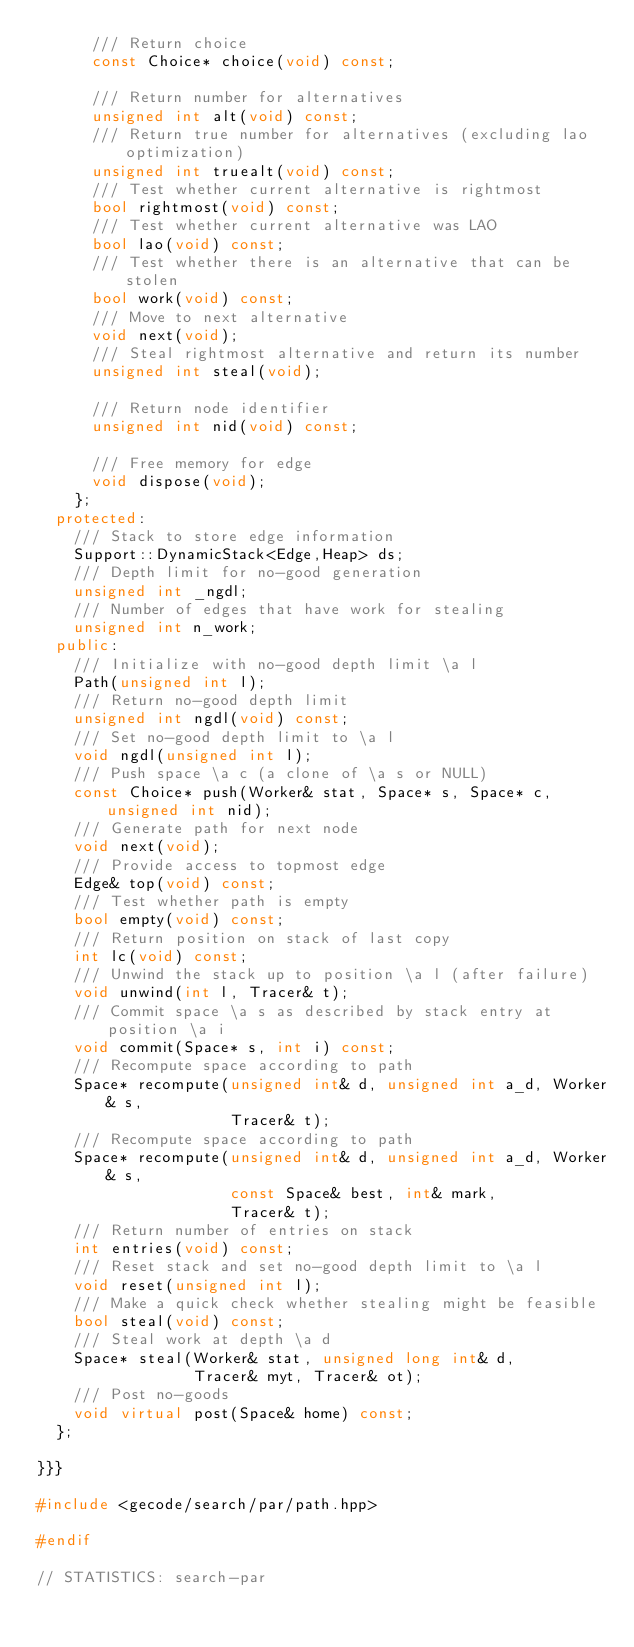Convert code to text. <code><loc_0><loc_0><loc_500><loc_500><_C++_>      /// Return choice
      const Choice* choice(void) const;

      /// Return number for alternatives
      unsigned int alt(void) const;
      /// Return true number for alternatives (excluding lao optimization)
      unsigned int truealt(void) const;
      /// Test whether current alternative is rightmost
      bool rightmost(void) const;
      /// Test whether current alternative was LAO
      bool lao(void) const;
      /// Test whether there is an alternative that can be stolen
      bool work(void) const;
      /// Move to next alternative
      void next(void);
      /// Steal rightmost alternative and return its number
      unsigned int steal(void);

      /// Return node identifier
      unsigned int nid(void) const;

      /// Free memory for edge
      void dispose(void);
    };
  protected:
    /// Stack to store edge information
    Support::DynamicStack<Edge,Heap> ds;
    /// Depth limit for no-good generation
    unsigned int _ngdl;
    /// Number of edges that have work for stealing
    unsigned int n_work;
  public:
    /// Initialize with no-good depth limit \a l
    Path(unsigned int l);
    /// Return no-good depth limit
    unsigned int ngdl(void) const;
    /// Set no-good depth limit to \a l
    void ngdl(unsigned int l);
    /// Push space \a c (a clone of \a s or NULL)
    const Choice* push(Worker& stat, Space* s, Space* c, unsigned int nid);
    /// Generate path for next node
    void next(void);
    /// Provide access to topmost edge
    Edge& top(void) const;
    /// Test whether path is empty
    bool empty(void) const;
    /// Return position on stack of last copy
    int lc(void) const;
    /// Unwind the stack up to position \a l (after failure)
    void unwind(int l, Tracer& t);
    /// Commit space \a s as described by stack entry at position \a i
    void commit(Space* s, int i) const;
    /// Recompute space according to path
    Space* recompute(unsigned int& d, unsigned int a_d, Worker& s,
                     Tracer& t);
    /// Recompute space according to path
    Space* recompute(unsigned int& d, unsigned int a_d, Worker& s,
                     const Space& best, int& mark,
                     Tracer& t);
    /// Return number of entries on stack
    int entries(void) const;
    /// Reset stack and set no-good depth limit to \a l
    void reset(unsigned int l);
    /// Make a quick check whether stealing might be feasible
    bool steal(void) const;
    /// Steal work at depth \a d
    Space* steal(Worker& stat, unsigned long int& d,
                 Tracer& myt, Tracer& ot);
    /// Post no-goods
    void virtual post(Space& home) const;
  };

}}}

#include <gecode/search/par/path.hpp>

#endif

// STATISTICS: search-par
</code> 